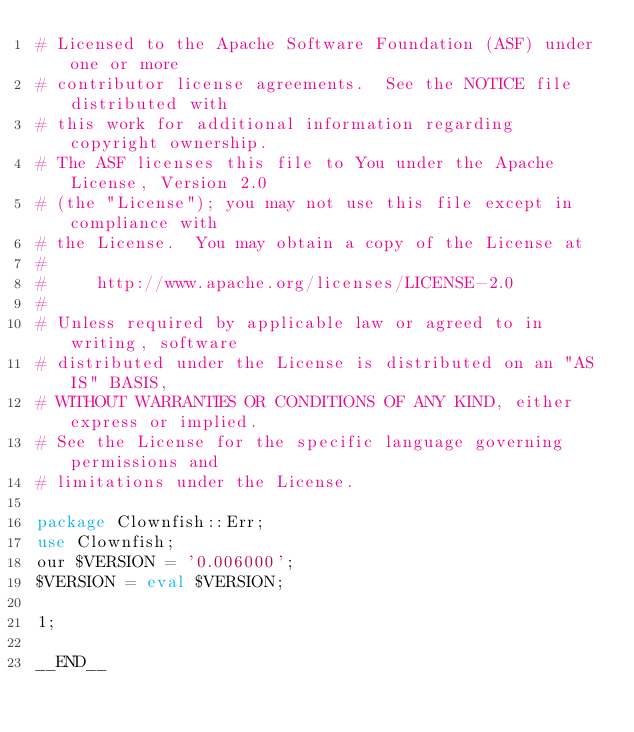<code> <loc_0><loc_0><loc_500><loc_500><_Perl_># Licensed to the Apache Software Foundation (ASF) under one or more
# contributor license agreements.  See the NOTICE file distributed with
# this work for additional information regarding copyright ownership.
# The ASF licenses this file to You under the Apache License, Version 2.0
# (the "License"); you may not use this file except in compliance with
# the License.  You may obtain a copy of the License at
#
#     http://www.apache.org/licenses/LICENSE-2.0
#
# Unless required by applicable law or agreed to in writing, software
# distributed under the License is distributed on an "AS IS" BASIS,
# WITHOUT WARRANTIES OR CONDITIONS OF ANY KIND, either express or implied.
# See the License for the specific language governing permissions and
# limitations under the License.

package Clownfish::Err;
use Clownfish;
our $VERSION = '0.006000';
$VERSION = eval $VERSION;

1;

__END__


</code> 